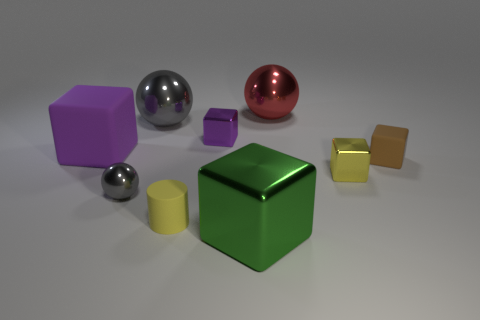Subtract all small yellow blocks. How many blocks are left? 4 Subtract 1 cubes. How many cubes are left? 4 Subtract all brown blocks. How many blocks are left? 4 Subtract all blue blocks. Subtract all purple balls. How many blocks are left? 5 Add 1 cyan blocks. How many objects exist? 10 Subtract all cylinders. How many objects are left? 8 Subtract all big spheres. Subtract all small yellow rubber things. How many objects are left? 6 Add 4 purple rubber things. How many purple rubber things are left? 5 Add 5 large gray objects. How many large gray objects exist? 6 Subtract 0 yellow balls. How many objects are left? 9 